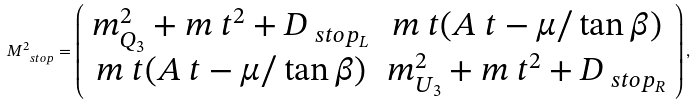Convert formula to latex. <formula><loc_0><loc_0><loc_500><loc_500>M ^ { 2 } _ { \ s t o p } = \left ( \begin{array} { c c } m _ { Q _ { 3 } } ^ { 2 } + m _ { \ } t ^ { 2 } + D _ { \ s t o p _ { L } } & m _ { \ } t ( A _ { \ } t - \mu / \tan \beta ) \\ m _ { \ } t ( A _ { \ } t - \mu / \tan \beta ) & m _ { U _ { 3 } } ^ { 2 } + m _ { \ } t ^ { 2 } + D _ { \ s t o p _ { R } } \\ \end{array} \right ) ,</formula> 